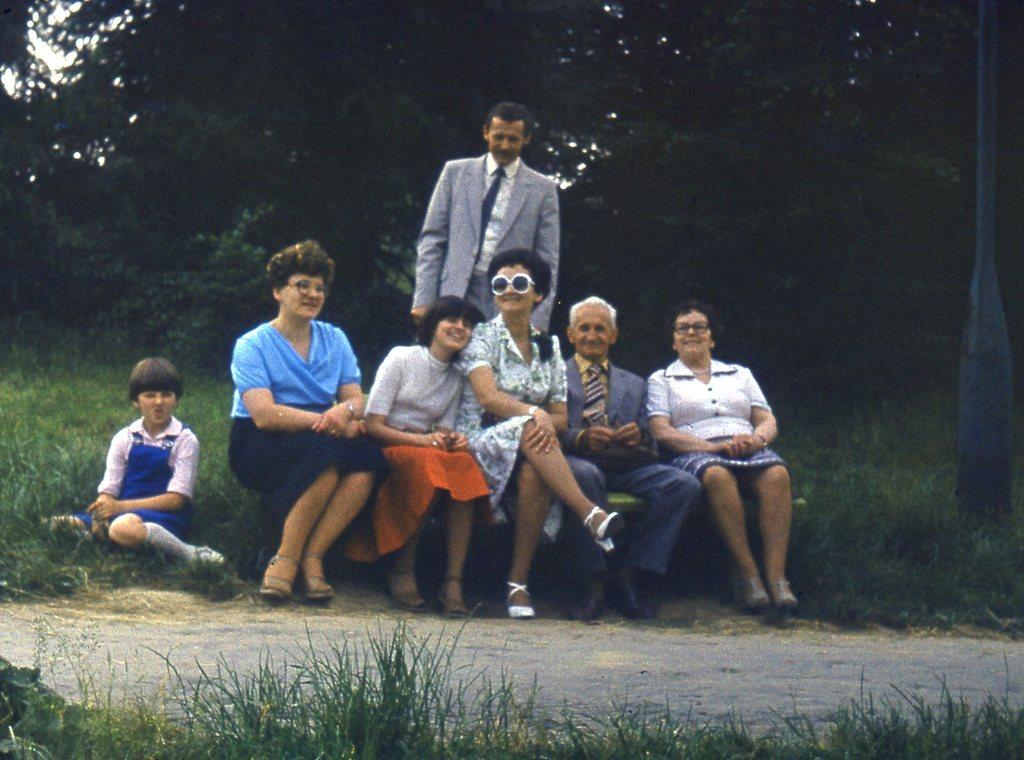What is the main activity of the people in the image? There is a group of people sitting in the image. Can you describe the person standing in the background? The person is wearing a gray blazer and a white shirt. What type of vegetation can be seen in the background of the image? There are trees with green color in the background of the image. What is the color of the sky in the image? The sky is visible in the background of the image and has a white color. What type of knee injury is the person in the image suffering from? There is no indication of a knee injury in the image; the person is standing and appears to be in good health. What type of waste management system is in place at the camp shown in the image? There is no camp present in the image, so it is not possible to determine the type of waste management system in place. 